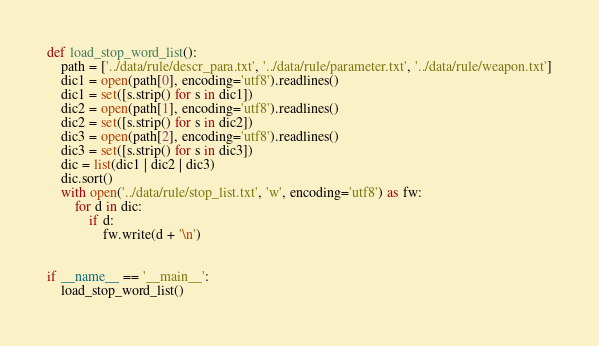Convert code to text. <code><loc_0><loc_0><loc_500><loc_500><_Python_>def load_stop_word_list():
    path = ['../data/rule/descr_para.txt', '../data/rule/parameter.txt', '../data/rule/weapon.txt']
    dic1 = open(path[0], encoding='utf8').readlines()
    dic1 = set([s.strip() for s in dic1])
    dic2 = open(path[1], encoding='utf8').readlines()
    dic2 = set([s.strip() for s in dic2])
    dic3 = open(path[2], encoding='utf8').readlines()
    dic3 = set([s.strip() for s in dic3])
    dic = list(dic1 | dic2 | dic3)
    dic.sort()
    with open('../data/rule/stop_list.txt', 'w', encoding='utf8') as fw:
        for d in dic:
            if d:
                fw.write(d + '\n')


if __name__ == '__main__':
    load_stop_word_list()
</code> 